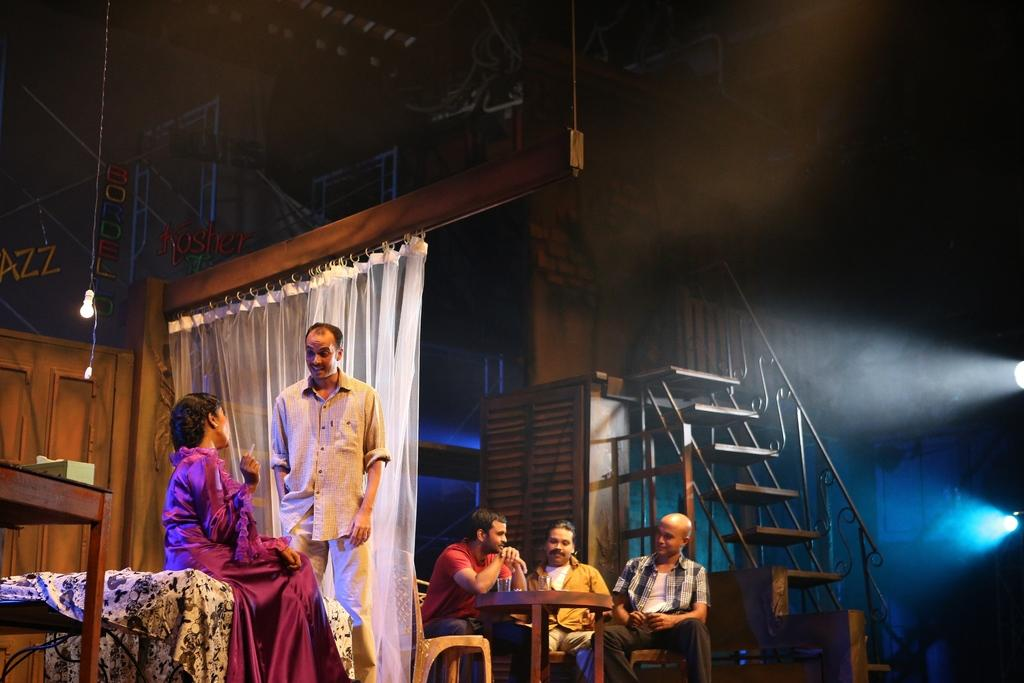How many people are in the image? There are people in the image, but the exact number is not specified. Can you describe the positions of the people in the image? One man is standing among the people, while other people are sitting. What can be seen in the background of the image? There are white color curtains in the image. Are there any architectural features in the image? Yes, there are steps in the image. What type of furniture is present in the image? There are chairs and a table in the image. What type of lighting is present in the image? There are lights in the image. What type of trucks can be seen parked near the people in the image? There are no trucks present in the image. What kind of joke is being told by the man standing among the people? There is no indication of a joke being told in the image. Is there a jail visible in the image? There is no jail present in the image. 